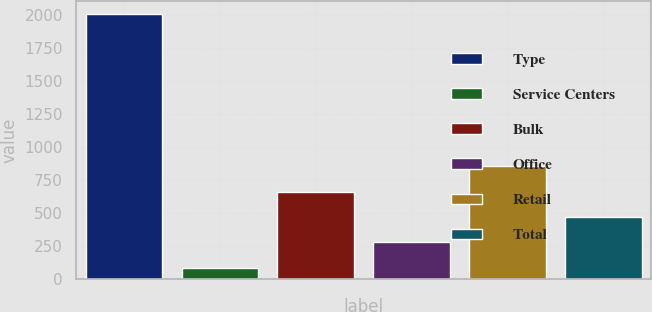Convert chart to OTSL. <chart><loc_0><loc_0><loc_500><loc_500><bar_chart><fcel>Type<fcel>Service Centers<fcel>Bulk<fcel>Office<fcel>Retail<fcel>Total<nl><fcel>2003<fcel>85.8<fcel>660.96<fcel>277.52<fcel>852.68<fcel>469.24<nl></chart> 